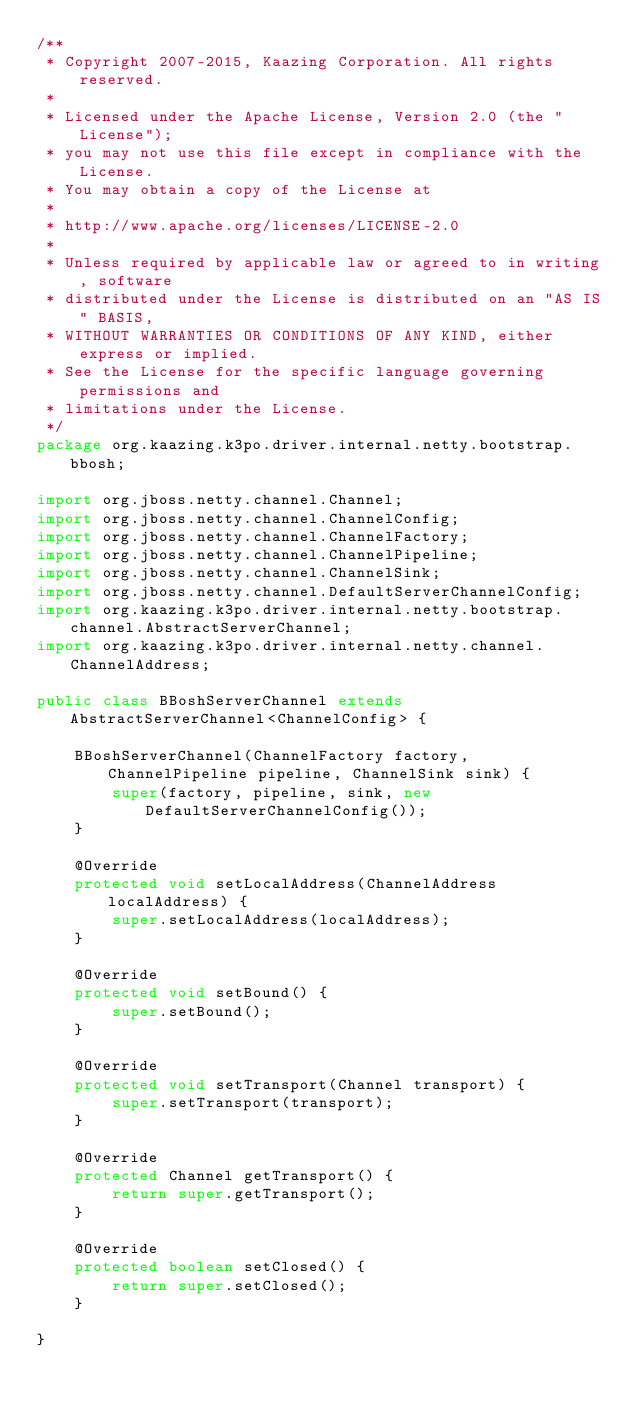Convert code to text. <code><loc_0><loc_0><loc_500><loc_500><_Java_>/**
 * Copyright 2007-2015, Kaazing Corporation. All rights reserved.
 *
 * Licensed under the Apache License, Version 2.0 (the "License");
 * you may not use this file except in compliance with the License.
 * You may obtain a copy of the License at
 *
 * http://www.apache.org/licenses/LICENSE-2.0
 *
 * Unless required by applicable law or agreed to in writing, software
 * distributed under the License is distributed on an "AS IS" BASIS,
 * WITHOUT WARRANTIES OR CONDITIONS OF ANY KIND, either express or implied.
 * See the License for the specific language governing permissions and
 * limitations under the License.
 */
package org.kaazing.k3po.driver.internal.netty.bootstrap.bbosh;

import org.jboss.netty.channel.Channel;
import org.jboss.netty.channel.ChannelConfig;
import org.jboss.netty.channel.ChannelFactory;
import org.jboss.netty.channel.ChannelPipeline;
import org.jboss.netty.channel.ChannelSink;
import org.jboss.netty.channel.DefaultServerChannelConfig;
import org.kaazing.k3po.driver.internal.netty.bootstrap.channel.AbstractServerChannel;
import org.kaazing.k3po.driver.internal.netty.channel.ChannelAddress;

public class BBoshServerChannel extends AbstractServerChannel<ChannelConfig> {

    BBoshServerChannel(ChannelFactory factory, ChannelPipeline pipeline, ChannelSink sink) {
        super(factory, pipeline, sink, new DefaultServerChannelConfig());
    }

    @Override
    protected void setLocalAddress(ChannelAddress localAddress) {
        super.setLocalAddress(localAddress);
    }

    @Override
    protected void setBound() {
        super.setBound();
    }

    @Override
    protected void setTransport(Channel transport) {
        super.setTransport(transport);
    }

    @Override
    protected Channel getTransport() {
        return super.getTransport();
    }

    @Override
    protected boolean setClosed() {
        return super.setClosed();
    }

}
</code> 